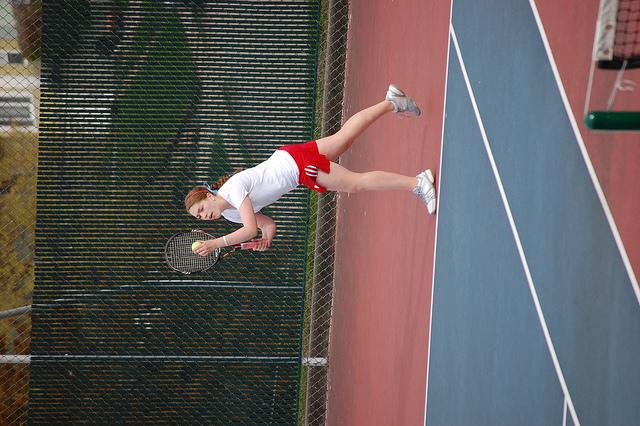Did she just catch the ball?
Write a very short answer. No. What color is the court?
Write a very short answer. Blue. Are these new sneakers?
Keep it brief. No. What sport is being played?
Keep it brief. Tennis. 